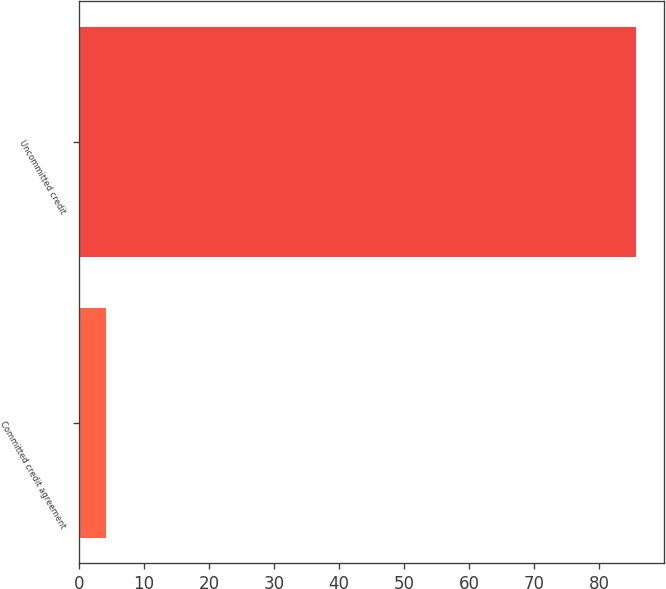<chart> <loc_0><loc_0><loc_500><loc_500><bar_chart><fcel>Committed credit agreement<fcel>Uncommitted credit<nl><fcel>4.14<fcel>85.7<nl></chart> 